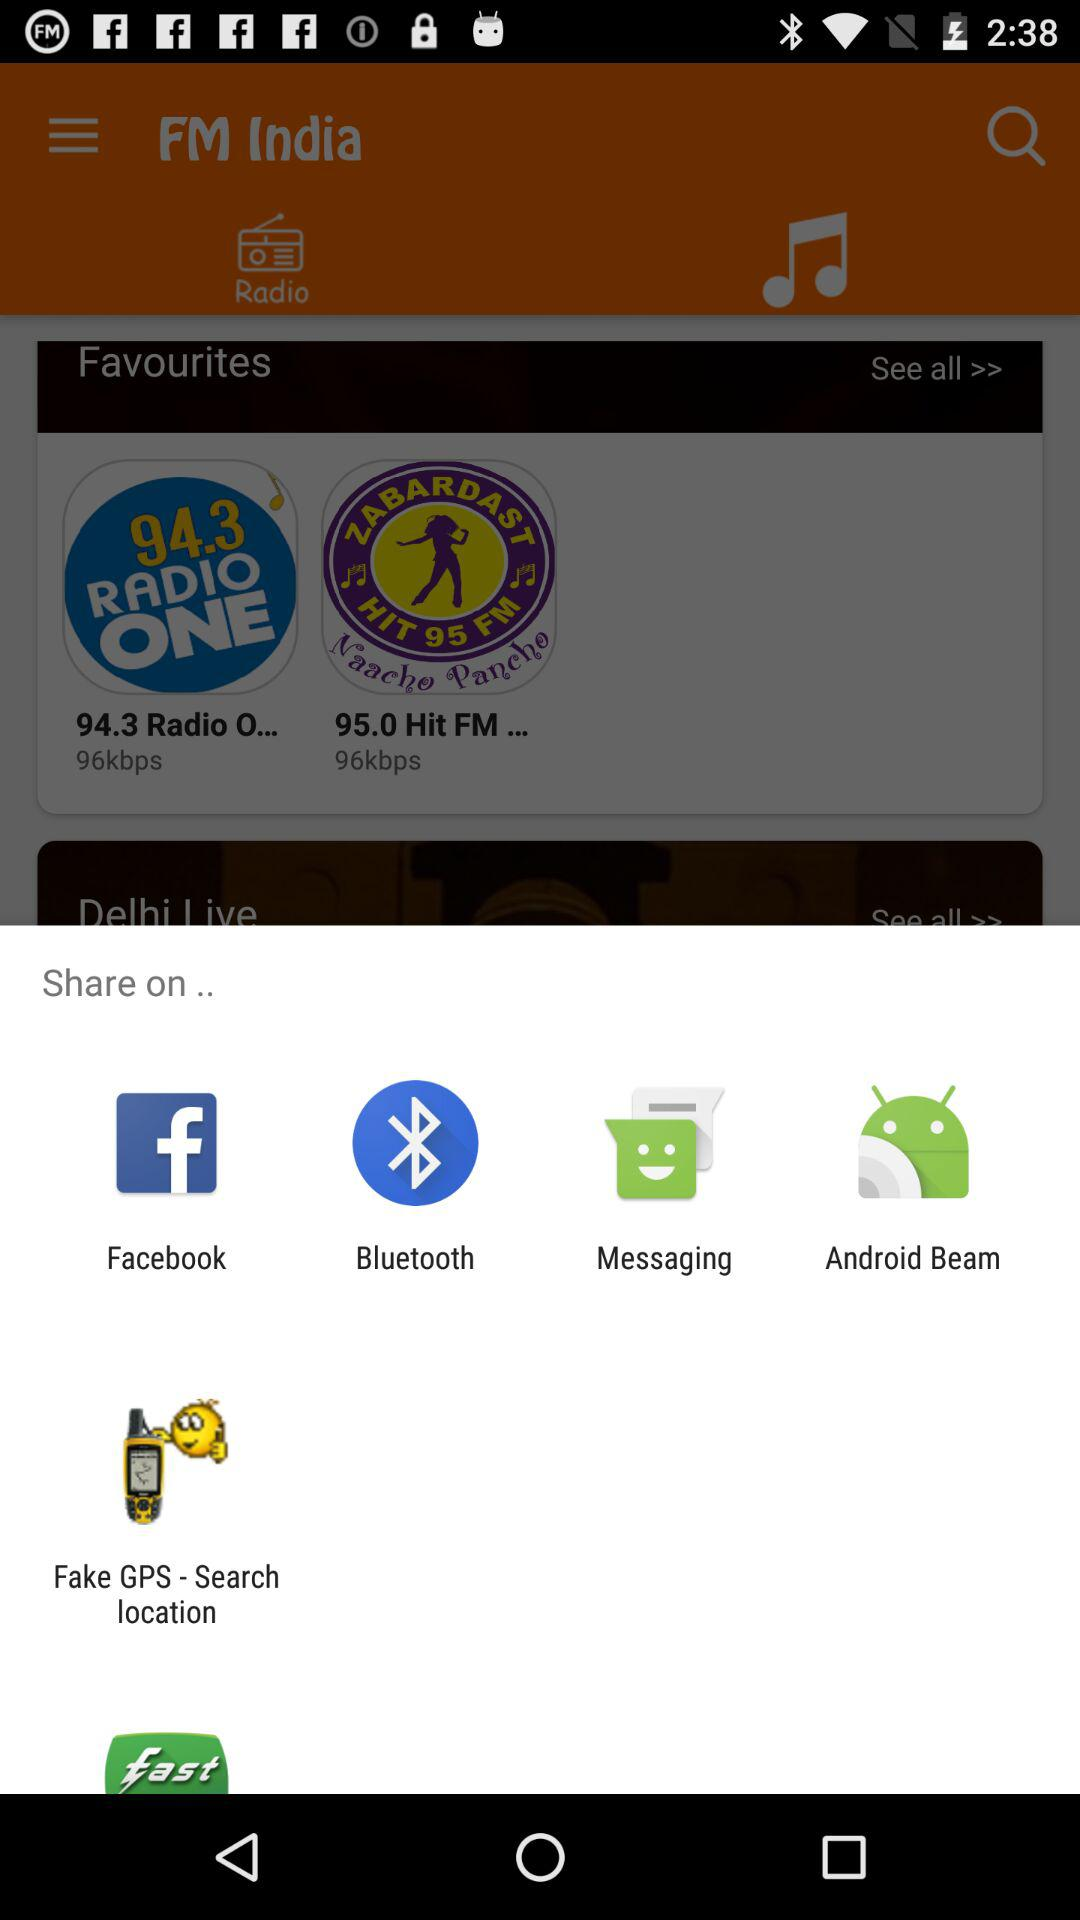Through which applications and mediums can the content be shared? The content can be shared through "Facebook", "Bluetooth", "Messaging", "Android Beam" and "Fake GPS - Search location". 